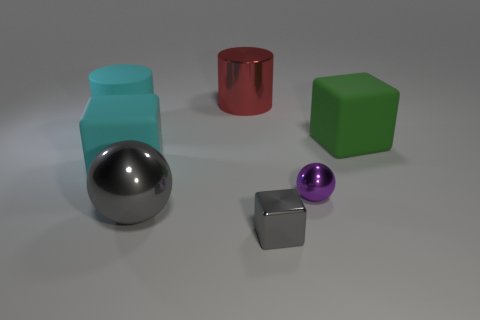Is there a gray block behind the cylinder on the right side of the cyan block?
Give a very brief answer. No. Is the size of the matte block that is on the left side of the gray ball the same as the gray block?
Offer a very short reply. No. What is the size of the metal cube?
Ensure brevity in your answer.  Small. Is there a tiny metallic ball of the same color as the big metal sphere?
Your answer should be very brief. No. What number of small things are purple spheres or gray shiny cubes?
Ensure brevity in your answer.  2. There is a block that is both in front of the green matte block and to the right of the large gray object; what size is it?
Make the answer very short. Small. How many cyan matte cylinders are to the left of the large green cube?
Keep it short and to the point. 1. What shape is the thing that is both behind the purple thing and to the right of the small gray metal object?
Your answer should be compact. Cube. What material is the thing that is the same color as the small block?
Your response must be concise. Metal. How many cylinders are purple things or gray metal things?
Give a very brief answer. 0. 